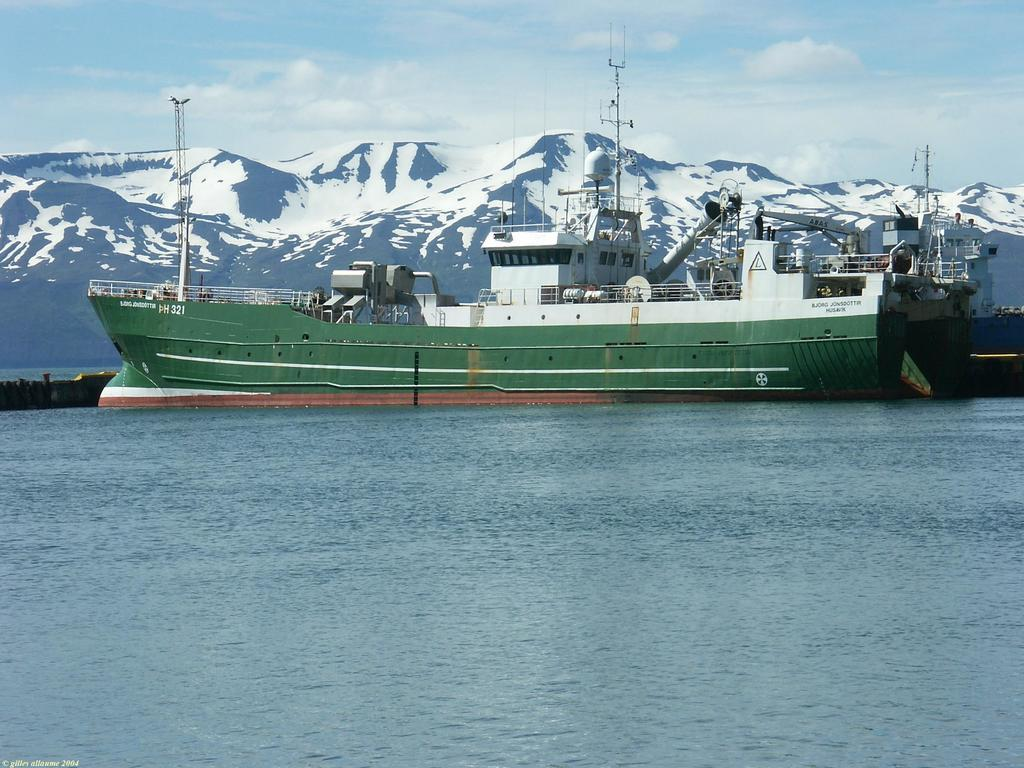What is the main subject of the image? The main subject of the image is a ship. Where is the ship located? The ship is on the water. What can be seen in the background of the image? There is a mountain and the sky visible in the background of the image. What is the condition of the sky in the image? The sky has clouds present in it. Can you tell me how many clams are visible on the ship in the image? There are no clams present on the ship in the image. What type of humor can be seen in the image? There is no humor depicted in the image; it features a ship on the water with a mountain and clouds in the background. 